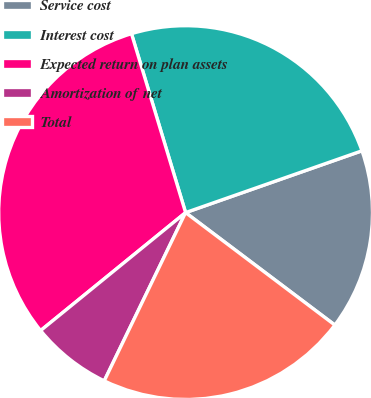Convert chart. <chart><loc_0><loc_0><loc_500><loc_500><pie_chart><fcel>Service cost<fcel>Interest cost<fcel>Expected return on plan assets<fcel>Amortization of net<fcel>Total<nl><fcel>15.64%<fcel>24.31%<fcel>31.2%<fcel>6.96%<fcel>21.89%<nl></chart> 